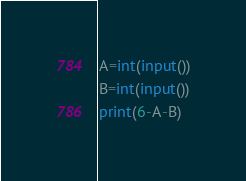<code> <loc_0><loc_0><loc_500><loc_500><_Python_>A=int(input())
B=int(input())
print(6-A-B)
</code> 